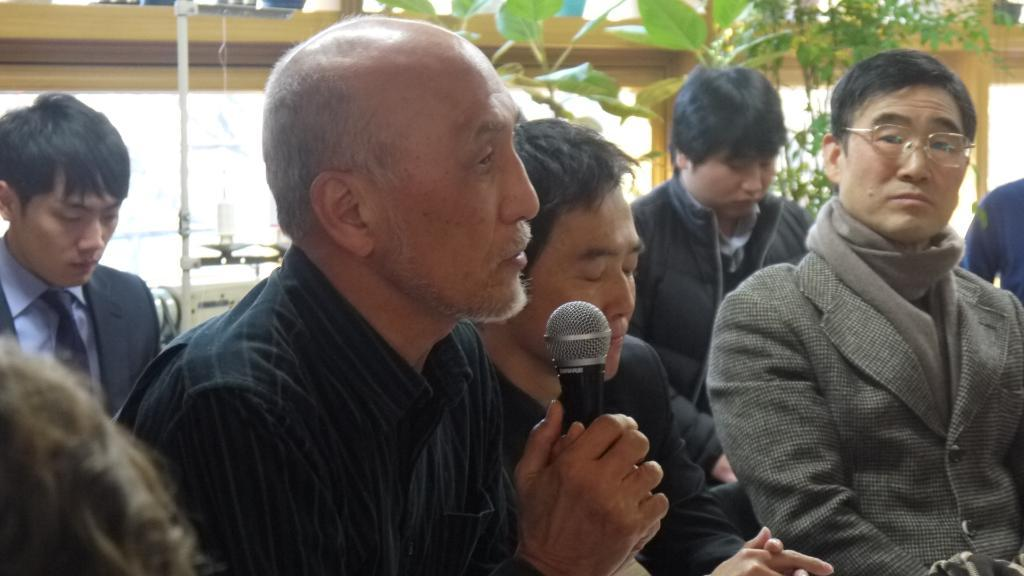What are the people in the image doing? The people in the image are sitting. What object is one man holding in the image? One man is holding a microphone in the image. What can be seen in the background of the image? There are plants, leaves, and a wooden ceiling in the background of the image. What type of bead is the father wearing in the image? There is no father or bead present in the image. What is the man holding the microphone saying in the image? The image does not provide any information about what the man is saying, as it is a still image and not a video or audio recording. 